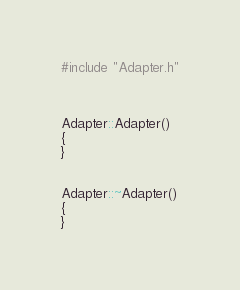Convert code to text. <code><loc_0><loc_0><loc_500><loc_500><_C++_>#include "Adapter.h"



Adapter::Adapter()
{
}


Adapter::~Adapter()
{
}
</code> 